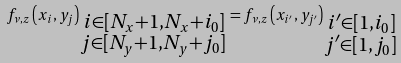<formula> <loc_0><loc_0><loc_500><loc_500>f _ { \nu , z } \left ( x _ { i } , y _ { j } \right ) _ { \substack { \, i \in [ N _ { x } + 1 , N _ { x } + i _ { 0 } ] \\ j \in [ N _ { y } + 1 , N _ { y } + j _ { 0 } ] } } = f _ { \nu , z } \left ( x _ { i ^ { \prime } } , y _ { j ^ { \prime } } \right ) _ { \substack { \, i ^ { \prime } \in [ 1 , i _ { 0 } ] \\ j ^ { \prime } \in [ 1 , j _ { 0 } ] } }</formula> 